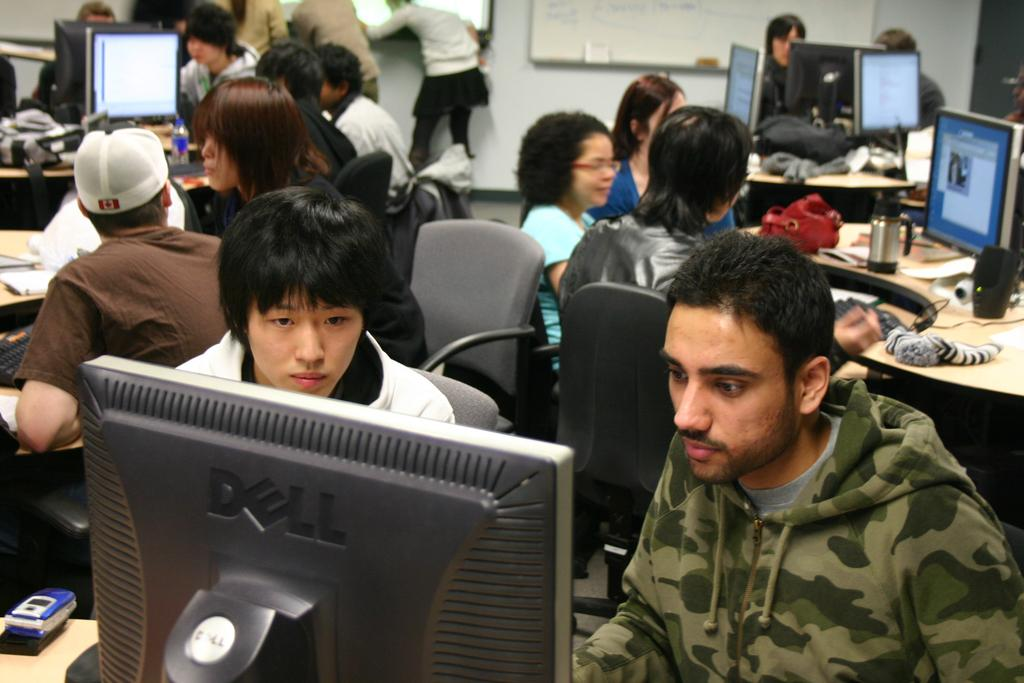What are the people in the image doing? People are sitting in groups at tables. What is in front of the people at the tables? There are monitors in front of the people. Can you describe the arrangement of the people and monitors? There are two men in front of a monitor. What type of canvas is being used by the people in the image? There is no canvas present in the image. What kind of competition are the people participating in? The image does not depict a competition, so it cannot be determined what type of competition the people might be participating in. 